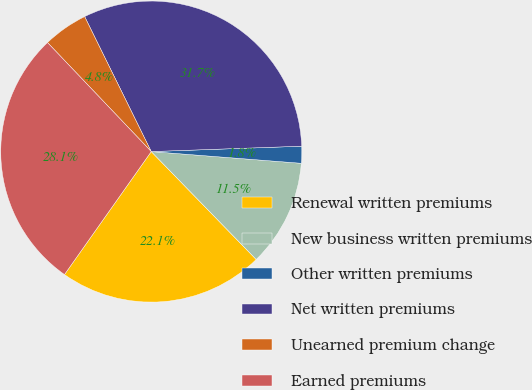<chart> <loc_0><loc_0><loc_500><loc_500><pie_chart><fcel>Renewal written premiums<fcel>New business written premiums<fcel>Other written premiums<fcel>Net written premiums<fcel>Unearned premium change<fcel>Earned premiums<nl><fcel>22.06%<fcel>11.48%<fcel>1.81%<fcel>31.73%<fcel>4.81%<fcel>28.11%<nl></chart> 